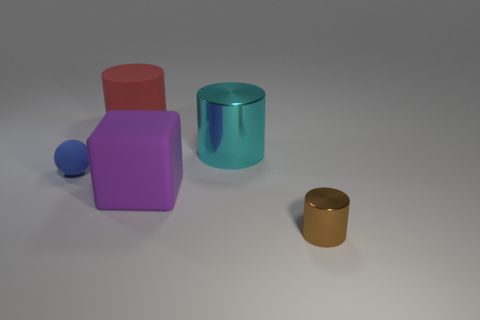Are the objects arranged in a specific pattern or randomly placed? The objects appear to be placed randomly on the surface, without any discernible pattern. 